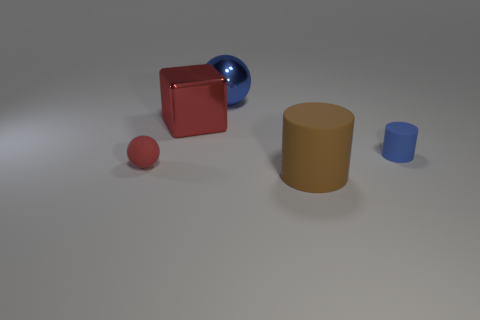Add 5 big cubes. How many objects exist? 10 Subtract all blue balls. How many balls are left? 1 Subtract all cylinders. How many objects are left? 3 Subtract 2 balls. How many balls are left? 0 Add 5 brown matte spheres. How many brown matte spheres exist? 5 Subtract 1 brown cylinders. How many objects are left? 4 Subtract all blue cubes. Subtract all purple balls. How many cubes are left? 1 Subtract all green balls. How many yellow cylinders are left? 0 Subtract all large brown objects. Subtract all metallic things. How many objects are left? 2 Add 1 blue metal spheres. How many blue metal spheres are left? 2 